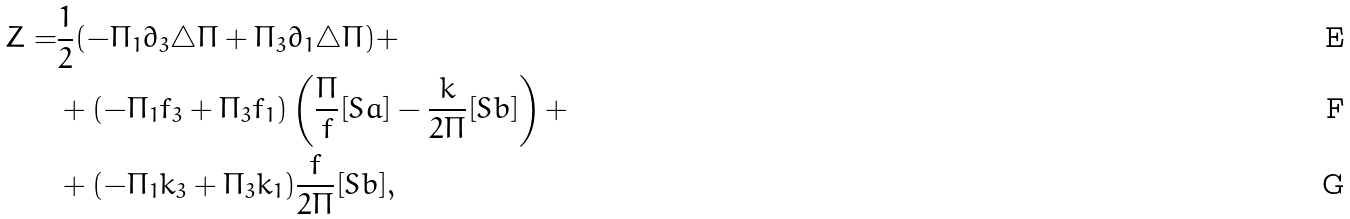Convert formula to latex. <formula><loc_0><loc_0><loc_500><loc_500>Z = & \frac { 1 } { 2 } ( - \Pi _ { 1 } \partial _ { 3 } \triangle \Pi + \Pi _ { 3 } \partial _ { 1 } \triangle \Pi ) + \\ & + ( - \Pi _ { 1 } f _ { 3 } + \Pi _ { 3 } f _ { 1 } ) \left ( \frac { \Pi } { f } [ S a ] - \frac { k } { 2 \Pi } [ S b ] \right ) + \\ & + ( - \Pi _ { 1 } k _ { 3 } + \Pi _ { 3 } k _ { 1 } ) \frac { f } { 2 \Pi } [ S b ] ,</formula> 